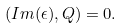<formula> <loc_0><loc_0><loc_500><loc_500>( I m ( \epsilon ) , Q ) = 0 .</formula> 